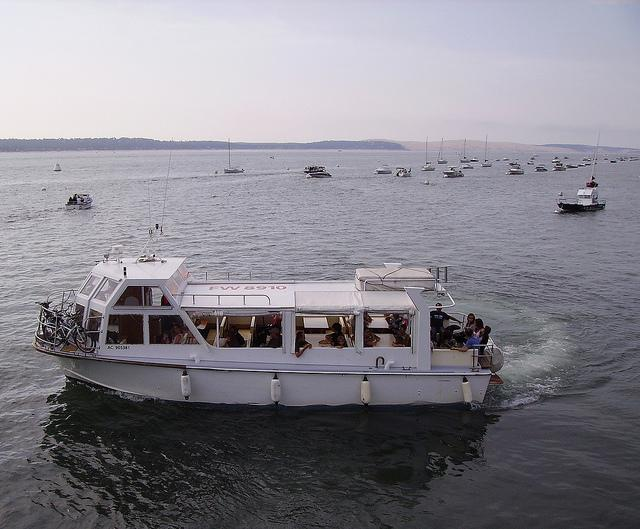What vehicle is stored in front of the boat? bicycles 